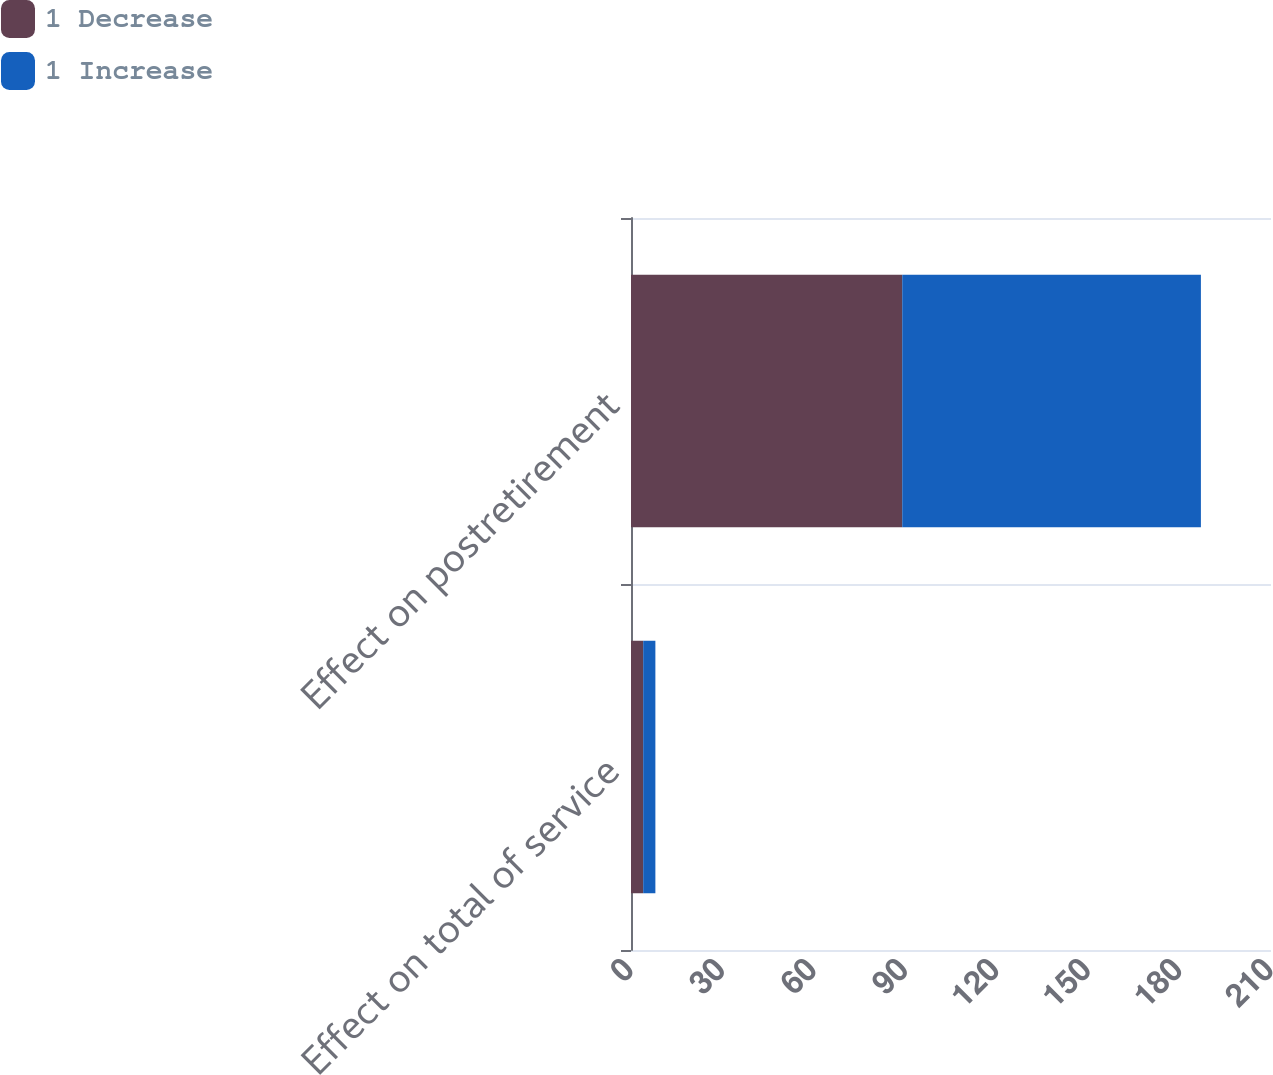Convert chart. <chart><loc_0><loc_0><loc_500><loc_500><stacked_bar_chart><ecel><fcel>Effect on total of service<fcel>Effect on postretirement<nl><fcel>1 Decrease<fcel>4<fcel>89<nl><fcel>1 Increase<fcel>4<fcel>98<nl></chart> 